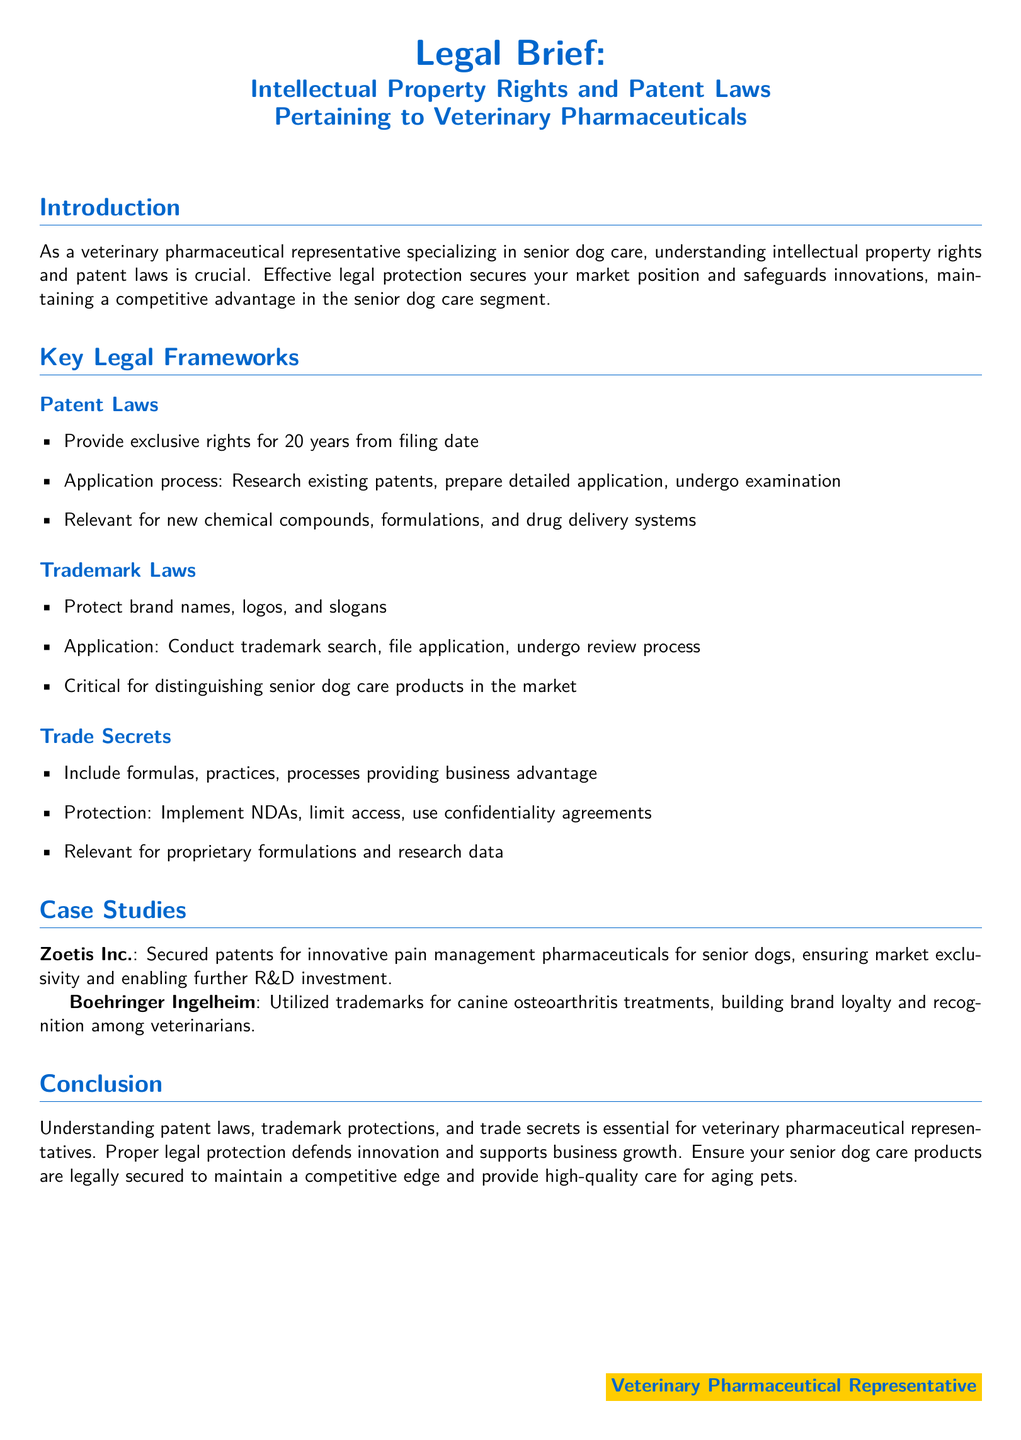What are the exclusive rights duration for patents? The document states that patents provide exclusive rights for 20 years from the filing date.
Answer: 20 years What company secured patents for innovative pain management pharmaceuticals? The document mentions Zoetis Inc. as the company that secured patents for innovative pain management pharmaceuticals for senior dogs.
Answer: Zoetis Inc What is the primary purpose of trademark laws? The document outlines that trademark laws protect brand names, logos, and slogans.
Answer: Protect brand names What type of protection is relevant for proprietary formulations? The document highlights that trade secrets include formulas that provide a business advantage.
Answer: Trade secrets What does the case study of Boehringer Ingelheim illustrate? The document states that Boehringer Ingelheim utilized trademarks for canine osteoarthritis treatments, building brand loyalty.
Answer: Brand loyalty What is required in the patent application process? According to the document, the patent application process includes researching existing patents and preparing a detailed application.
Answer: Research and application preparation What should be limited to protect trade secrets? The document indicates that limiting access is important to protect trade secrets.
Answer: Access What enhances recognition of senior dog care products? The document suggests that trademarks enhance the recognition of senior dog care products in the market.
Answer: Trademarks What type of law protects logos? The document identifies trademark laws as the protection for logos among other things.
Answer: Trademark laws 